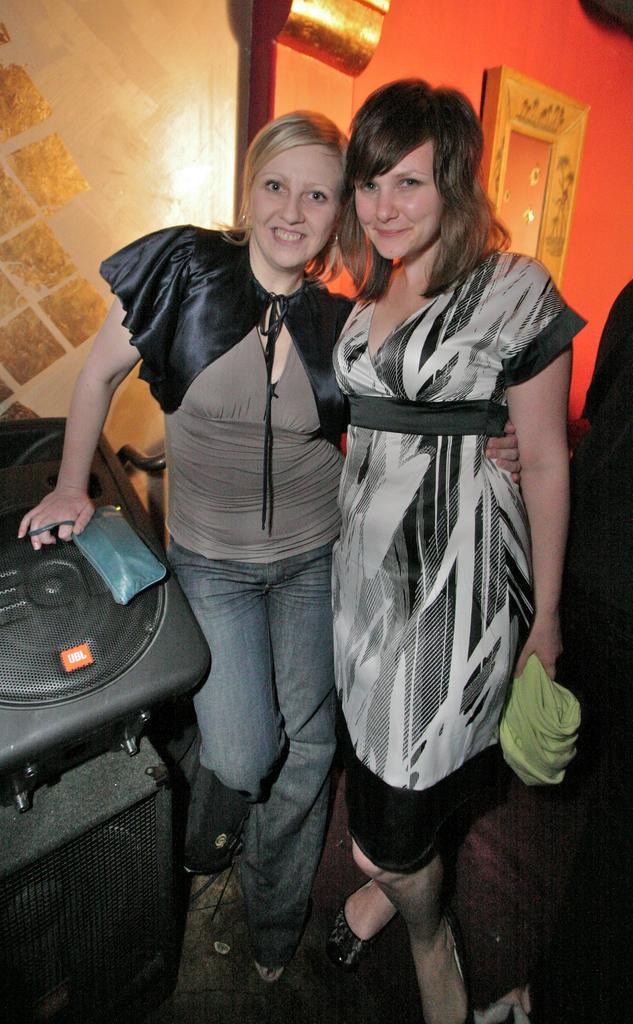How many people are in the image? There are two women in the image. What are the women doing in the image? The women are standing and smiling. What are the women holding in the image? The women are holding something. What can be seen in the background of the image? There is a wall in the background of the image. What type of shirt is the butter wearing in the image? There is no butter present in the image, and therefore no shirt to describe. 